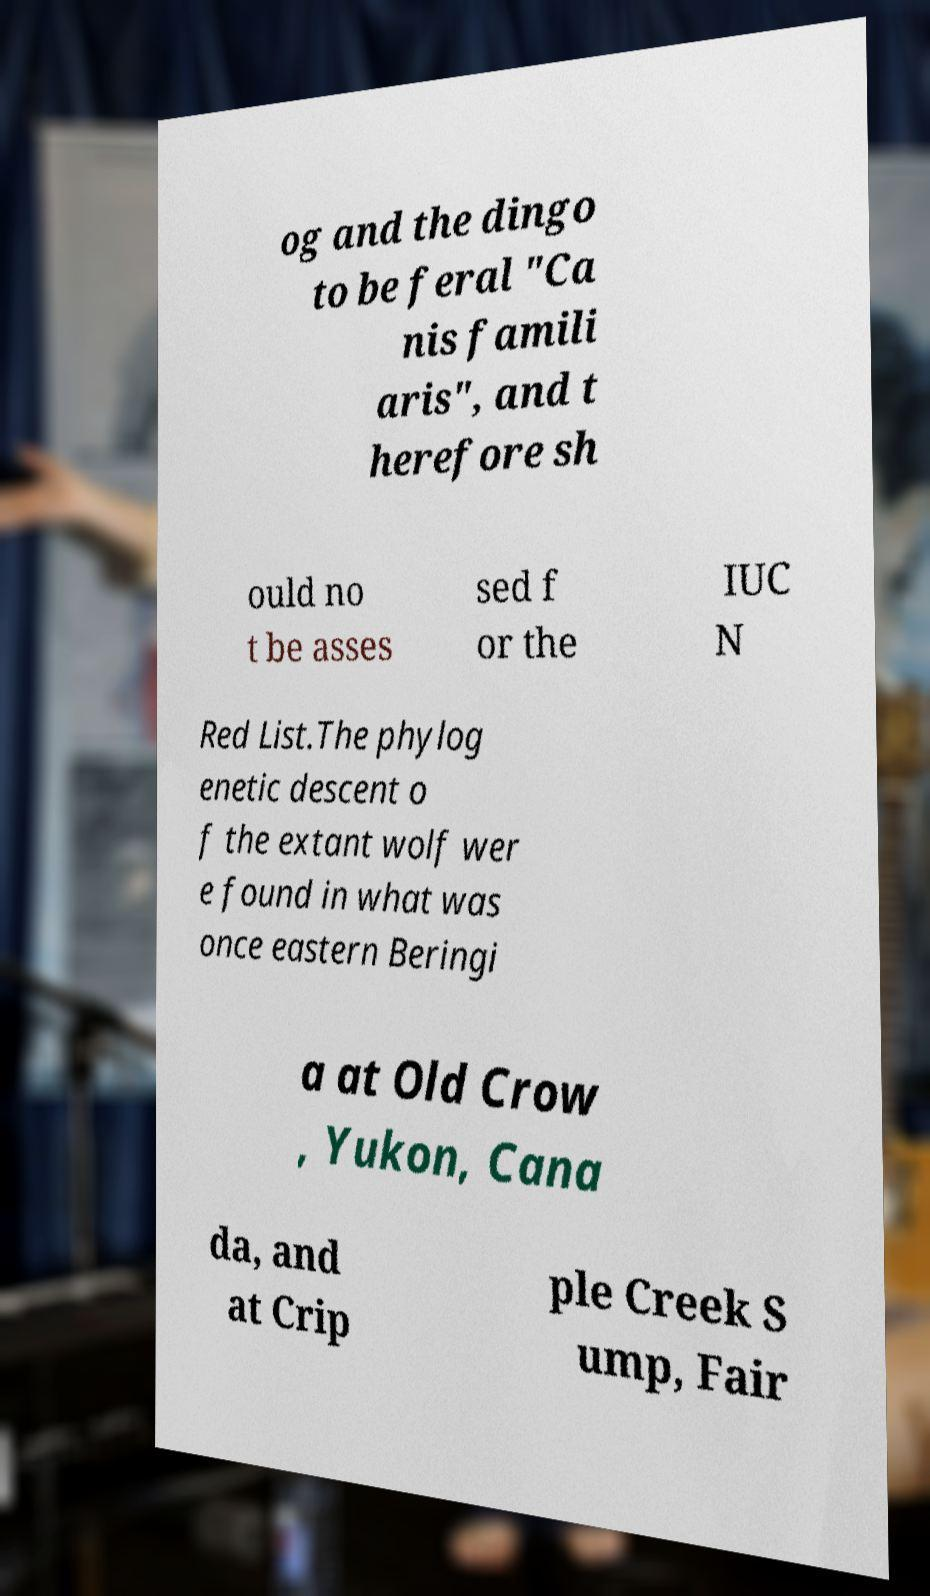Could you assist in decoding the text presented in this image and type it out clearly? og and the dingo to be feral "Ca nis famili aris", and t herefore sh ould no t be asses sed f or the IUC N Red List.The phylog enetic descent o f the extant wolf wer e found in what was once eastern Beringi a at Old Crow , Yukon, Cana da, and at Crip ple Creek S ump, Fair 